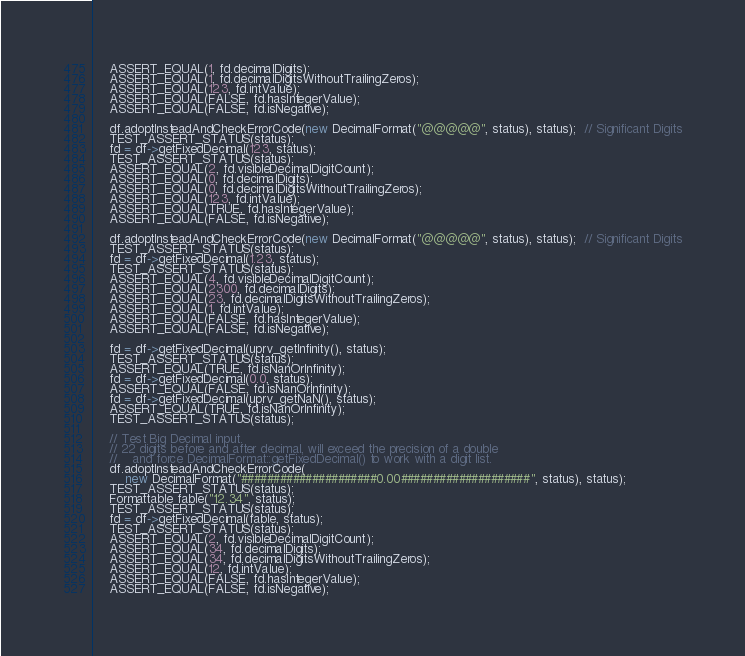Convert code to text. <code><loc_0><loc_0><loc_500><loc_500><_C++_>    ASSERT_EQUAL(1, fd.decimalDigits);
    ASSERT_EQUAL(1, fd.decimalDigitsWithoutTrailingZeros);
    ASSERT_EQUAL(123, fd.intValue);
    ASSERT_EQUAL(FALSE, fd.hasIntegerValue);
    ASSERT_EQUAL(FALSE, fd.isNegative);

    df.adoptInsteadAndCheckErrorCode(new DecimalFormat("@@@@@", status), status);  // Significant Digits
    TEST_ASSERT_STATUS(status);
    fd = df->getFixedDecimal(123, status);
    TEST_ASSERT_STATUS(status);
    ASSERT_EQUAL(2, fd.visibleDecimalDigitCount);
    ASSERT_EQUAL(0, fd.decimalDigits);
    ASSERT_EQUAL(0, fd.decimalDigitsWithoutTrailingZeros);
    ASSERT_EQUAL(123, fd.intValue);
    ASSERT_EQUAL(TRUE, fd.hasIntegerValue);
    ASSERT_EQUAL(FALSE, fd.isNegative);

    df.adoptInsteadAndCheckErrorCode(new DecimalFormat("@@@@@", status), status);  // Significant Digits
    TEST_ASSERT_STATUS(status);
    fd = df->getFixedDecimal(1.23, status);
    TEST_ASSERT_STATUS(status);
    ASSERT_EQUAL(4, fd.visibleDecimalDigitCount);
    ASSERT_EQUAL(2300, fd.decimalDigits);
    ASSERT_EQUAL(23, fd.decimalDigitsWithoutTrailingZeros);
    ASSERT_EQUAL(1, fd.intValue);
    ASSERT_EQUAL(FALSE, fd.hasIntegerValue);
    ASSERT_EQUAL(FALSE, fd.isNegative);

    fd = df->getFixedDecimal(uprv_getInfinity(), status);
    TEST_ASSERT_STATUS(status);
    ASSERT_EQUAL(TRUE, fd.isNanOrInfinity);
    fd = df->getFixedDecimal(0.0, status);
    ASSERT_EQUAL(FALSE, fd.isNanOrInfinity);
    fd = df->getFixedDecimal(uprv_getNaN(), status);
    ASSERT_EQUAL(TRUE, fd.isNanOrInfinity);
    TEST_ASSERT_STATUS(status);

    // Test Big Decimal input.
    // 22 digits before and after decimal, will exceed the precision of a double
    //    and force DecimalFormat::getFixedDecimal() to work with a digit list.
    df.adoptInsteadAndCheckErrorCode(
        new DecimalFormat("#####################0.00####################", status), status);
    TEST_ASSERT_STATUS(status);
    Formattable fable("12.34", status);
    TEST_ASSERT_STATUS(status);
    fd = df->getFixedDecimal(fable, status);
    TEST_ASSERT_STATUS(status);
    ASSERT_EQUAL(2, fd.visibleDecimalDigitCount);
    ASSERT_EQUAL(34, fd.decimalDigits);
    ASSERT_EQUAL(34, fd.decimalDigitsWithoutTrailingZeros);
    ASSERT_EQUAL(12, fd.intValue);
    ASSERT_EQUAL(FALSE, fd.hasIntegerValue);
    ASSERT_EQUAL(FALSE, fd.isNegative);
</code> 